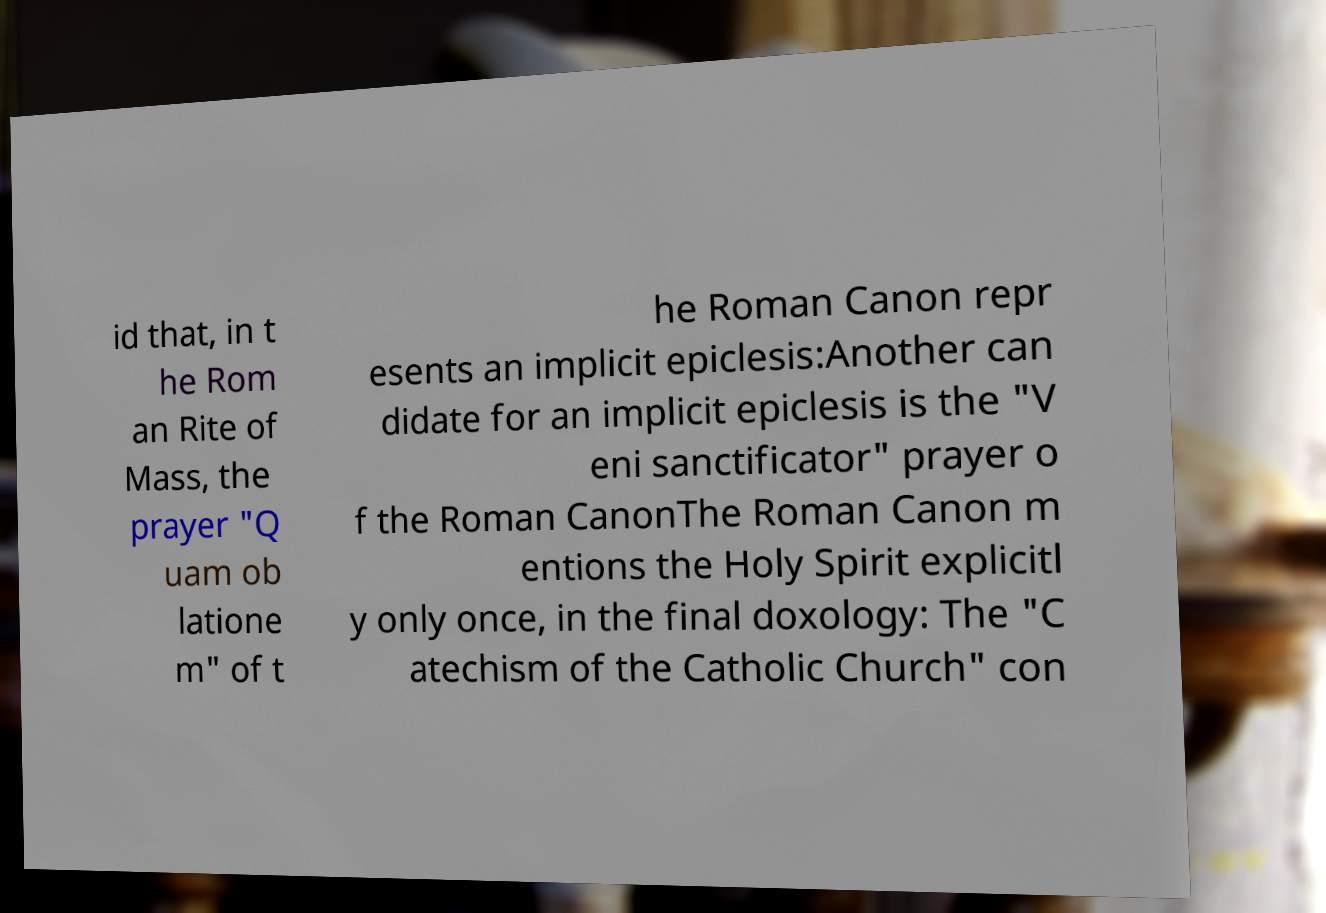For documentation purposes, I need the text within this image transcribed. Could you provide that? id that, in t he Rom an Rite of Mass, the prayer "Q uam ob latione m" of t he Roman Canon repr esents an implicit epiclesis:Another can didate for an implicit epiclesis is the "V eni sanctificator" prayer o f the Roman CanonThe Roman Canon m entions the Holy Spirit explicitl y only once, in the final doxology: The "C atechism of the Catholic Church" con 